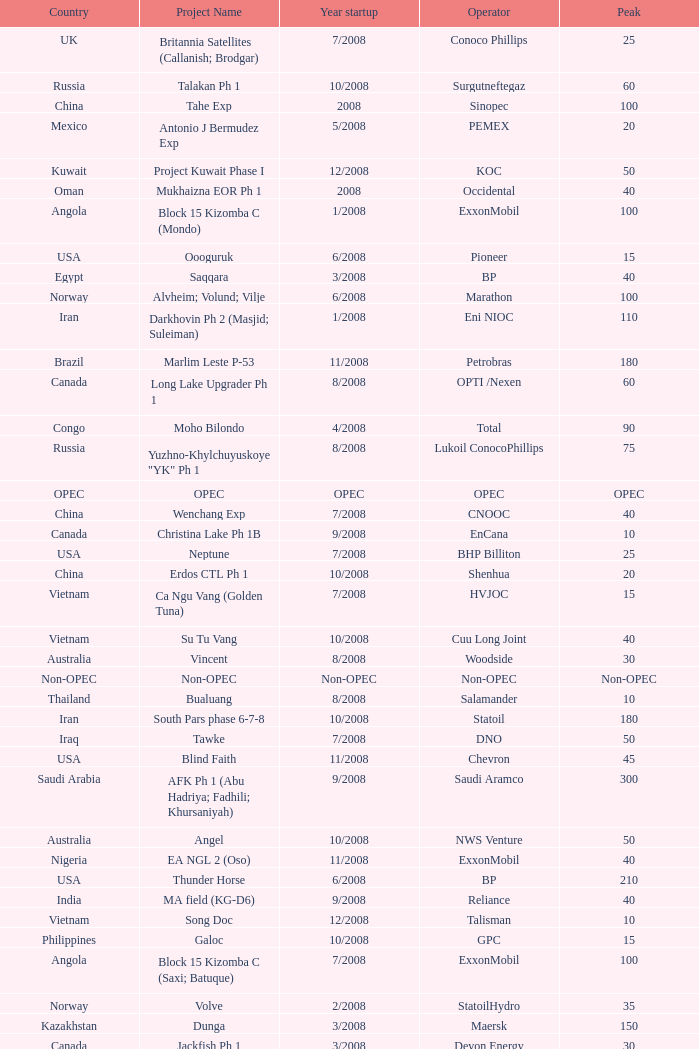What is the Project Name with a Country that is kazakhstan and a Peak that is 150? Dunga. 